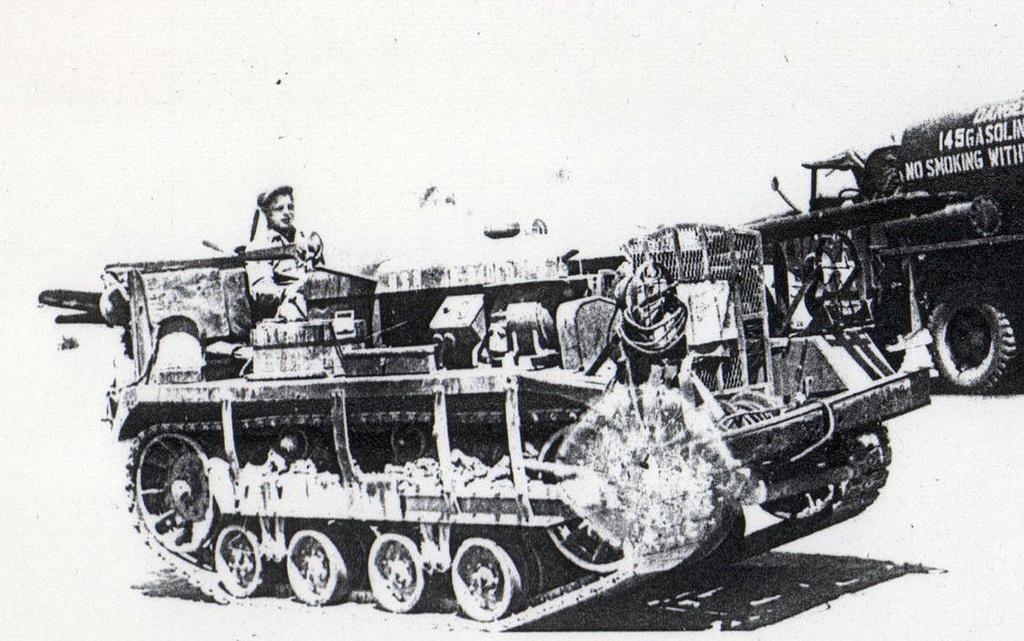What is the color scheme of the image? The image is black and white. What is the main subject of the image? There is a war tanker in the image. Is there anyone on the war tanker? Yes, there is a person on the war tanker. What type of marble is being used to decorate the home in the image? There is no home or marble present in the image; it features a war tanker with a person on it. 